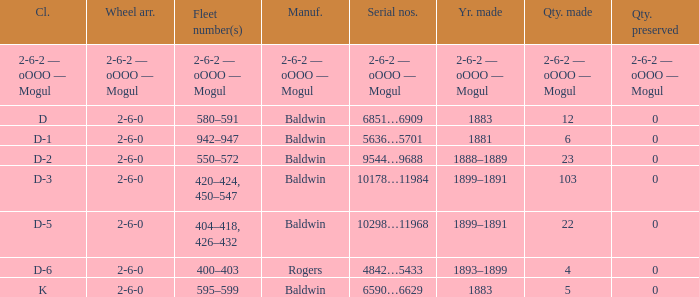What is the quantity made when the wheel arrangement is 2-6-0 and the class is k? 5.0. 